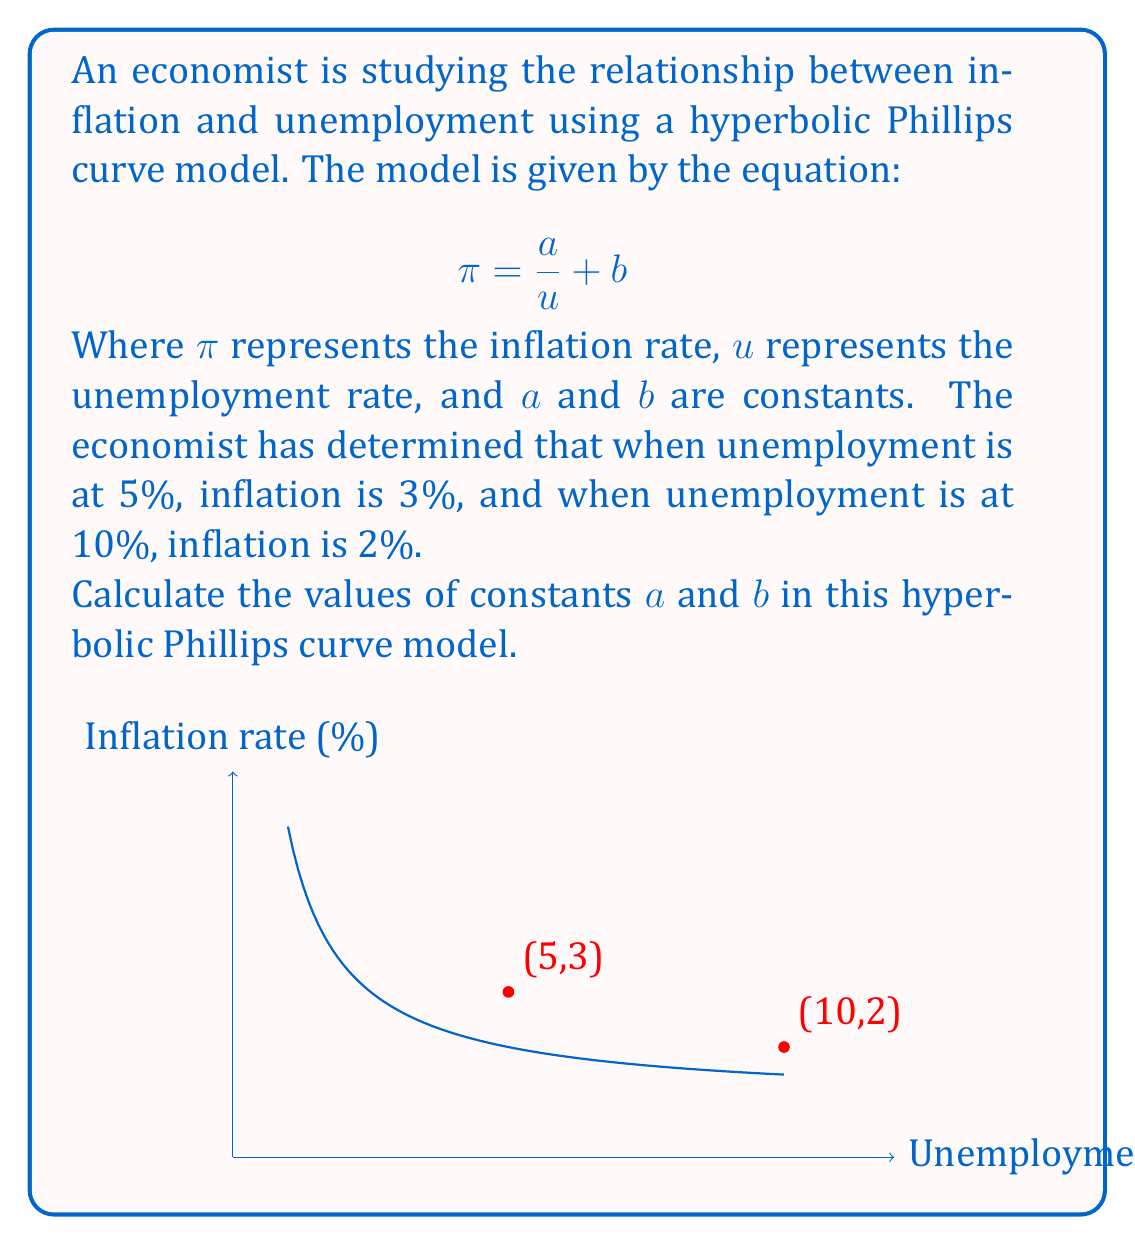Could you help me with this problem? Let's solve this step-by-step:

1) We have two points that satisfy the equation: (5,3) and (10,2). Let's plug these into our equation:

   For (5,3): $3 = \frac{a}{5} + b$
   For (10,2): $2 = \frac{a}{10} + b$

2) Subtract the second equation from the first:

   $3 - 2 = \frac{a}{5} - \frac{a}{10}$
   $1 = \frac{2a}{10} - \frac{a}{10} = \frac{a}{10}$

3) Solve for $a$:

   $a = 10$

4) Now that we know $a$, let's plug it back into one of our original equations. Let's use (5,3):

   $3 = \frac{10}{5} + b$
   $3 = 2 + b$

5) Solve for $b$:

   $b = 3 - 2 = 1$

Therefore, the constants in the hyperbolic Phillips curve model are $a = 10$ and $b = 1$.
Answer: $a = 10$, $b = 1$ 